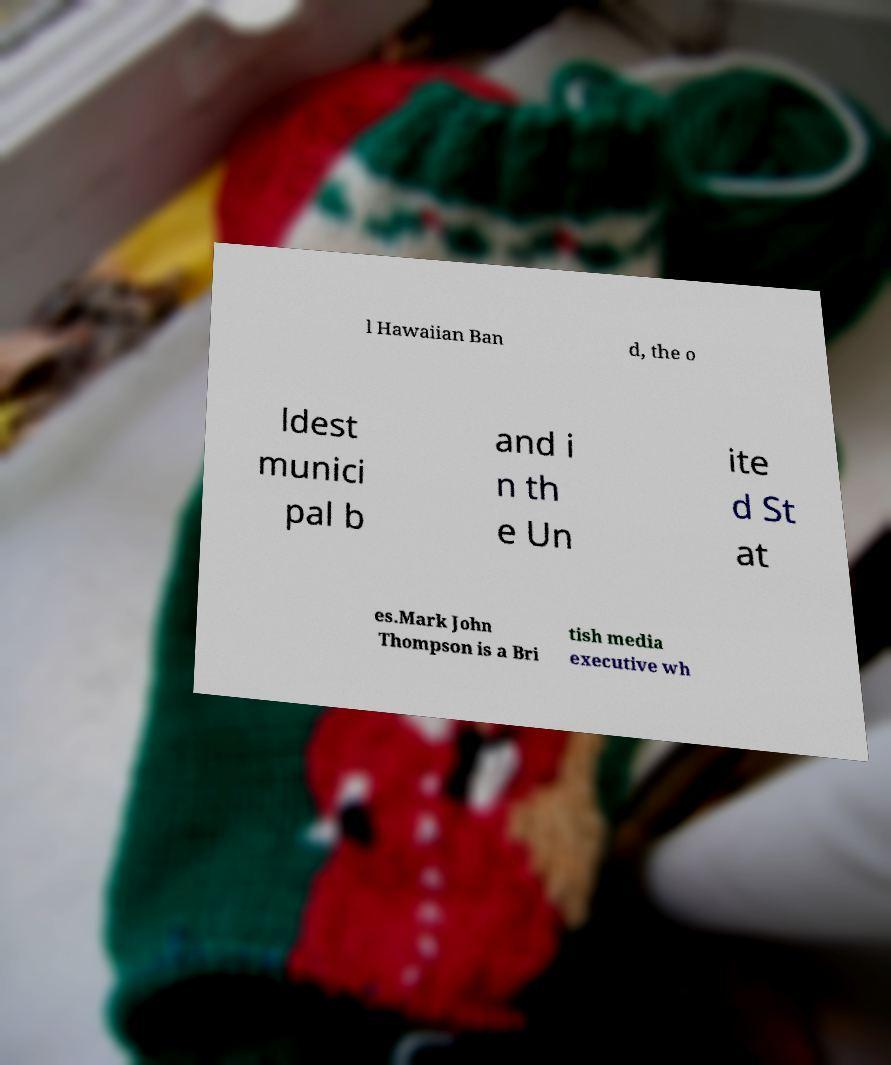What messages or text are displayed in this image? I need them in a readable, typed format. l Hawaiian Ban d, the o ldest munici pal b and i n th e Un ite d St at es.Mark John Thompson is a Bri tish media executive wh 